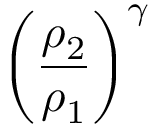Convert formula to latex. <formula><loc_0><loc_0><loc_500><loc_500>\left ( { \frac { \rho _ { 2 } } { \rho _ { 1 } } } \right ) ^ { \gamma }</formula> 